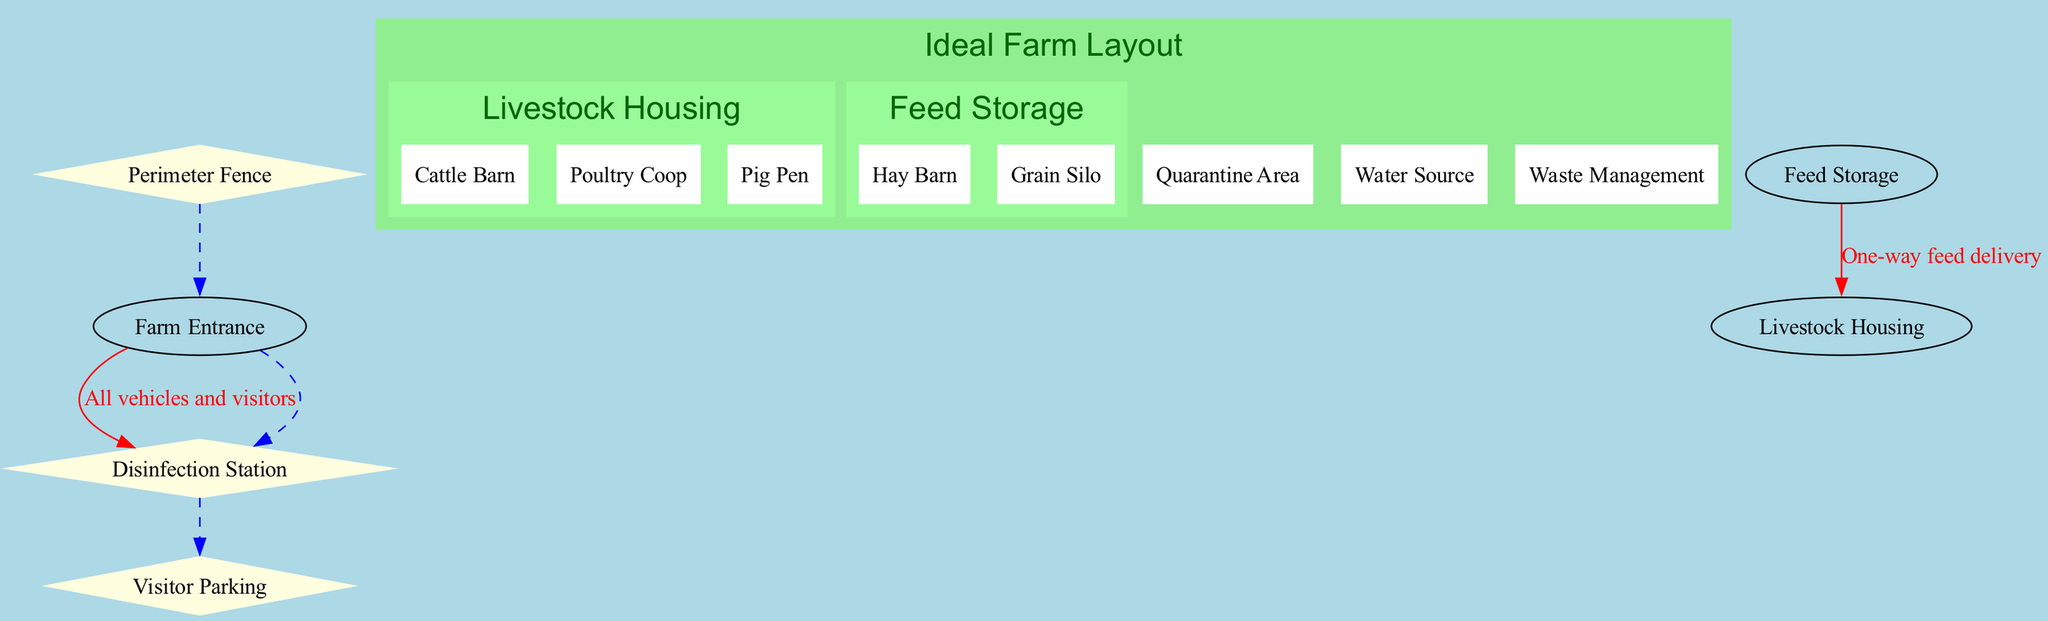What are the three main areas depicted in the diagram? The diagram shows 'Livestock Housing', 'Quarantine Area', 'Feed Storage', 'Water Source', and 'Waste Management' as the primary areas. However, focusing on the distinct categories mentioned at the start, the three main areas could refer to specific housing areas shown under 'Livestock Housing'.
Answer: Cattle Barn, Poultry Coop, Pig Pen How many sub-areas are present in the 'Feed Storage' section? The 'Feed Storage' section contains two sub-areas: 'Hay Barn' and 'Grain Silo'. This means that within this main area, there are two distinct storage types for feeding livestock.
Answer: 2 What is the purpose of the 'Quarantine Area'? The 'Quarantine Area' is specified in the diagram for newly arrived animals, indicating its role in preventing potential contamination and ensuring health before integration.
Answer: For newly arrived animals What does the traffic flow from 'Farm Entrance' to 'Disinfection Station' indicate? The traffic flow description signifies that all vehicles and visitors must first stop at the disinfection station upon arrival at the farm, highlighting a key biosecurity measure implemented to minimize disease spread.
Answer: All vehicles and visitors Which biosecurity measure surrounds the entire farm? The diagram specifies that the 'Perimeter Fence' surrounds the entire farm, which is a critical barrier for isolating the farm premises from outside contact.
Answer: Perimeter Fence What are the two specific types of livestock housing identified in the diagram? Within the 'Livestock Housing' area, the diagram outlines specific types of housing, identifying 'Cattle Barn' and 'Poultry Coop' as examples of dedicated spaces for particular livestock categories.
Answer: Cattle Barn, Poultry Coop What type of flow does the line connecting 'Feed Storage' to 'Livestock Housing' represent? The one-way feed delivery flow emphasizes the efficient transportation of feed directly from the storage facility to the livestock housing section, ensuring streamlined operations and minimizing cross-contamination.
Answer: One-way feed delivery How many biosecurity measures are outlined in the diagram? The diagram lists three distinct biosecurity measures that are incorporated into the layout design to enhance the overall safety and health of the livestock management environment.
Answer: 3 